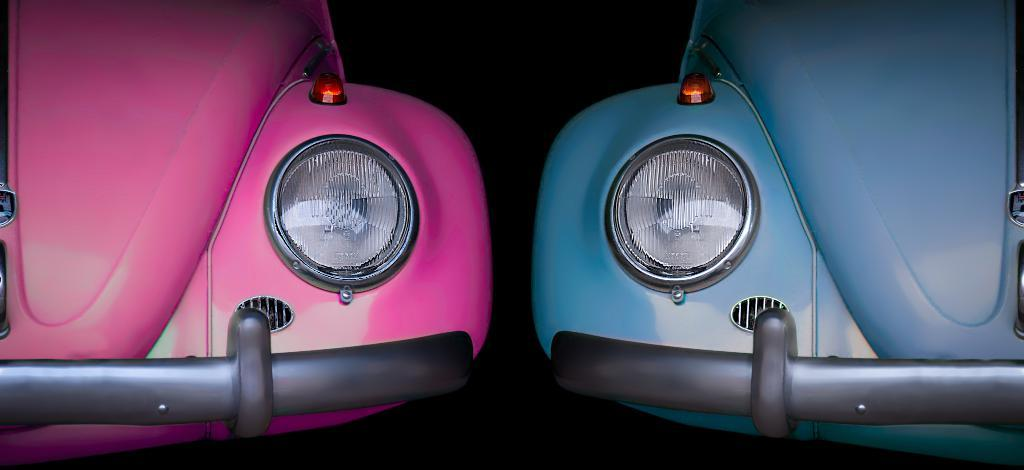How many cars are in the image? There are two cars in the image. What colors are the cars? One car is pink, and the other is blue. What features do the cars have? The cars have headlights, indicator lights, and bumpers. What can be observed about the background of the image? The background of the image appears dark. What type of vegetable is being used as a voice amplifier in the image? There is no vegetable or voice amplifier present in the image. 